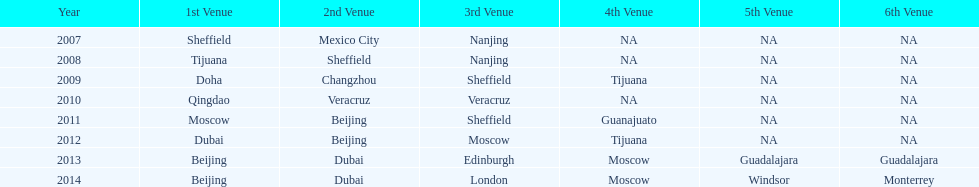What years had the most venues? 2013, 2014. 